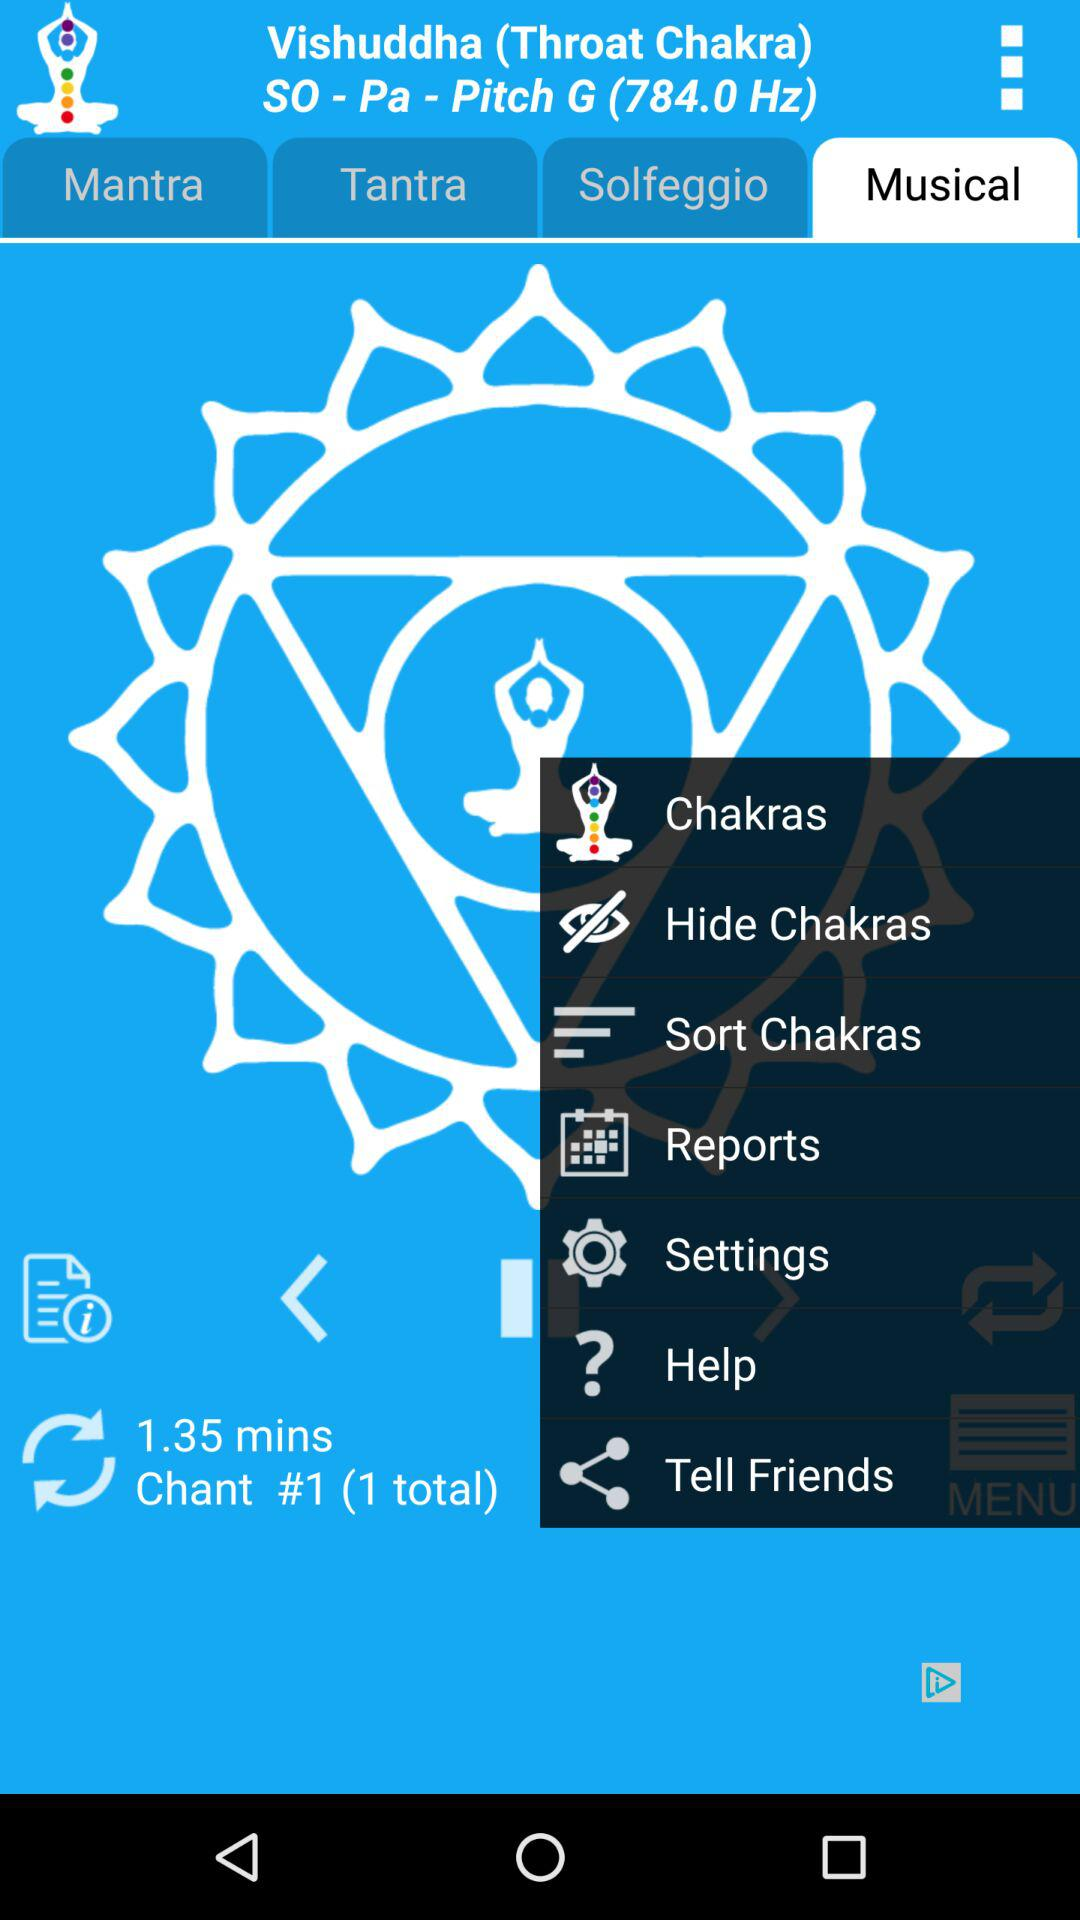What is total number of chants? The total number of chants is 1. 